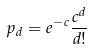<formula> <loc_0><loc_0><loc_500><loc_500>p _ { d } = e ^ { - c } \frac { c ^ { d } } { d ! }</formula> 